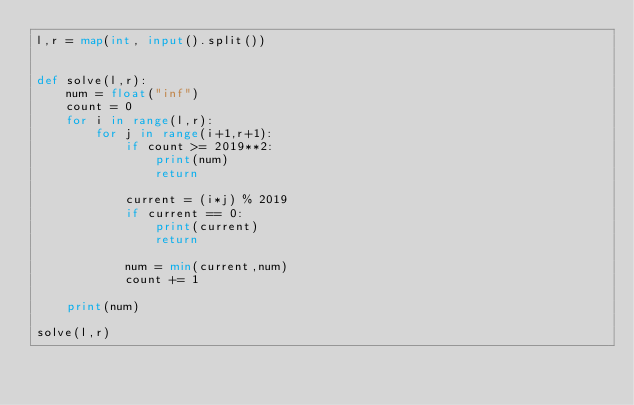<code> <loc_0><loc_0><loc_500><loc_500><_Python_>l,r = map(int, input().split())


def solve(l,r):
    num = float("inf")
    count = 0
    for i in range(l,r):
        for j in range(i+1,r+1):
            if count >= 2019**2:
                print(num)
                return
            
            current = (i*j) % 2019
            if current == 0:
                print(current)
                return
            
            num = min(current,num)
            count += 1
    
    print(num)

solve(l,r)</code> 